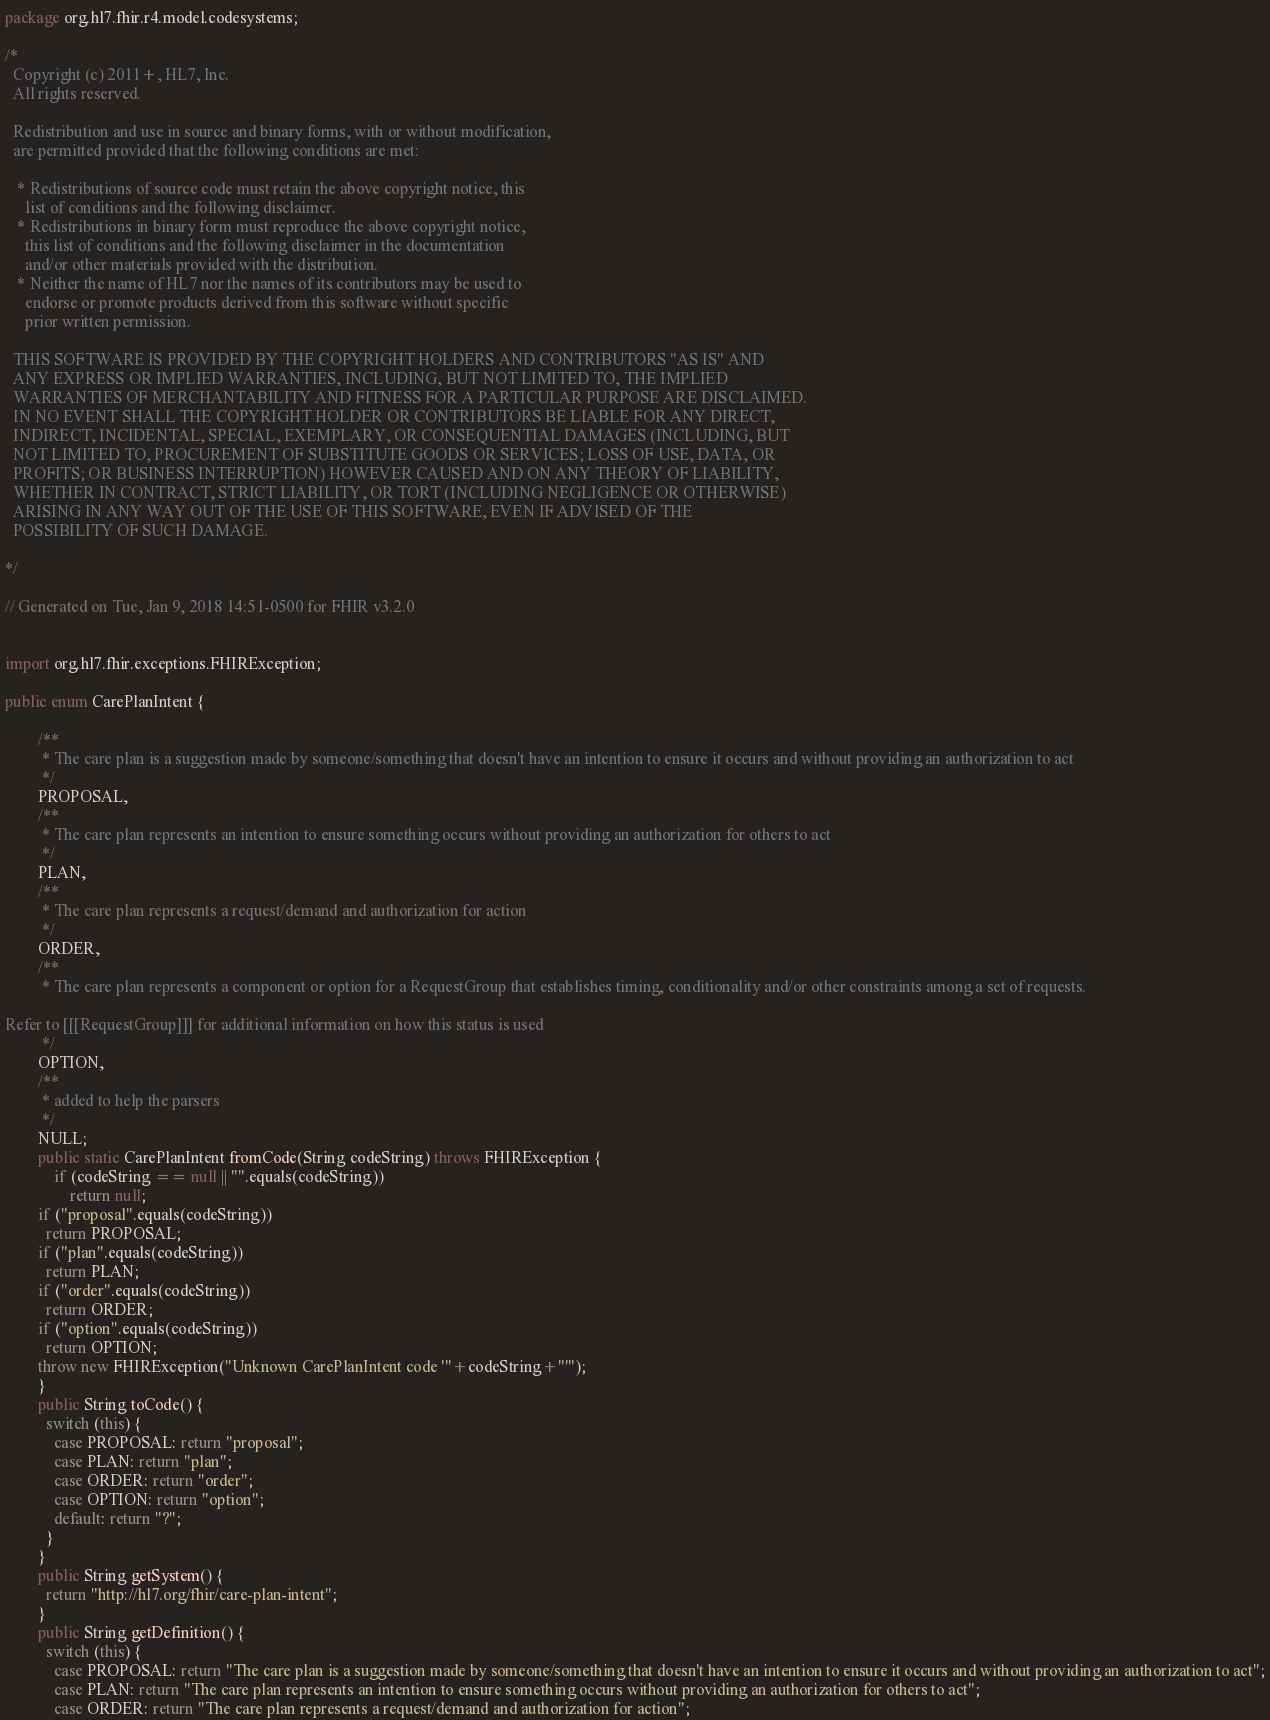<code> <loc_0><loc_0><loc_500><loc_500><_Java_>package org.hl7.fhir.r4.model.codesystems;

/*
  Copyright (c) 2011+, HL7, Inc.
  All rights reserved.
  
  Redistribution and use in source and binary forms, with or without modification, 
  are permitted provided that the following conditions are met:
  
   * Redistributions of source code must retain the above copyright notice, this 
     list of conditions and the following disclaimer.
   * Redistributions in binary form must reproduce the above copyright notice, 
     this list of conditions and the following disclaimer in the documentation 
     and/or other materials provided with the distribution.
   * Neither the name of HL7 nor the names of its contributors may be used to 
     endorse or promote products derived from this software without specific 
     prior written permission.
  
  THIS SOFTWARE IS PROVIDED BY THE COPYRIGHT HOLDERS AND CONTRIBUTORS "AS IS" AND 
  ANY EXPRESS OR IMPLIED WARRANTIES, INCLUDING, BUT NOT LIMITED TO, THE IMPLIED 
  WARRANTIES OF MERCHANTABILITY AND FITNESS FOR A PARTICULAR PURPOSE ARE DISCLAIMED. 
  IN NO EVENT SHALL THE COPYRIGHT HOLDER OR CONTRIBUTORS BE LIABLE FOR ANY DIRECT, 
  INDIRECT, INCIDENTAL, SPECIAL, EXEMPLARY, OR CONSEQUENTIAL DAMAGES (INCLUDING, BUT 
  NOT LIMITED TO, PROCUREMENT OF SUBSTITUTE GOODS OR SERVICES; LOSS OF USE, DATA, OR 
  PROFITS; OR BUSINESS INTERRUPTION) HOWEVER CAUSED AND ON ANY THEORY OF LIABILITY, 
  WHETHER IN CONTRACT, STRICT LIABILITY, OR TORT (INCLUDING NEGLIGENCE OR OTHERWISE) 
  ARISING IN ANY WAY OUT OF THE USE OF THIS SOFTWARE, EVEN IF ADVISED OF THE 
  POSSIBILITY OF SUCH DAMAGE.
  
*/

// Generated on Tue, Jan 9, 2018 14:51-0500 for FHIR v3.2.0


import org.hl7.fhir.exceptions.FHIRException;

public enum CarePlanIntent {

        /**
         * The care plan is a suggestion made by someone/something that doesn't have an intention to ensure it occurs and without providing an authorization to act
         */
        PROPOSAL, 
        /**
         * The care plan represents an intention to ensure something occurs without providing an authorization for others to act
         */
        PLAN, 
        /**
         * The care plan represents a request/demand and authorization for action
         */
        ORDER, 
        /**
         * The care plan represents a component or option for a RequestGroup that establishes timing, conditionality and/or other constraints among a set of requests.

Refer to [[[RequestGroup]]] for additional information on how this status is used
         */
        OPTION, 
        /**
         * added to help the parsers
         */
        NULL;
        public static CarePlanIntent fromCode(String codeString) throws FHIRException {
            if (codeString == null || "".equals(codeString))
                return null;
        if ("proposal".equals(codeString))
          return PROPOSAL;
        if ("plan".equals(codeString))
          return PLAN;
        if ("order".equals(codeString))
          return ORDER;
        if ("option".equals(codeString))
          return OPTION;
        throw new FHIRException("Unknown CarePlanIntent code '"+codeString+"'");
        }
        public String toCode() {
          switch (this) {
            case PROPOSAL: return "proposal";
            case PLAN: return "plan";
            case ORDER: return "order";
            case OPTION: return "option";
            default: return "?";
          }
        }
        public String getSystem() {
          return "http://hl7.org/fhir/care-plan-intent";
        }
        public String getDefinition() {
          switch (this) {
            case PROPOSAL: return "The care plan is a suggestion made by someone/something that doesn't have an intention to ensure it occurs and without providing an authorization to act";
            case PLAN: return "The care plan represents an intention to ensure something occurs without providing an authorization for others to act";
            case ORDER: return "The care plan represents a request/demand and authorization for action";</code> 